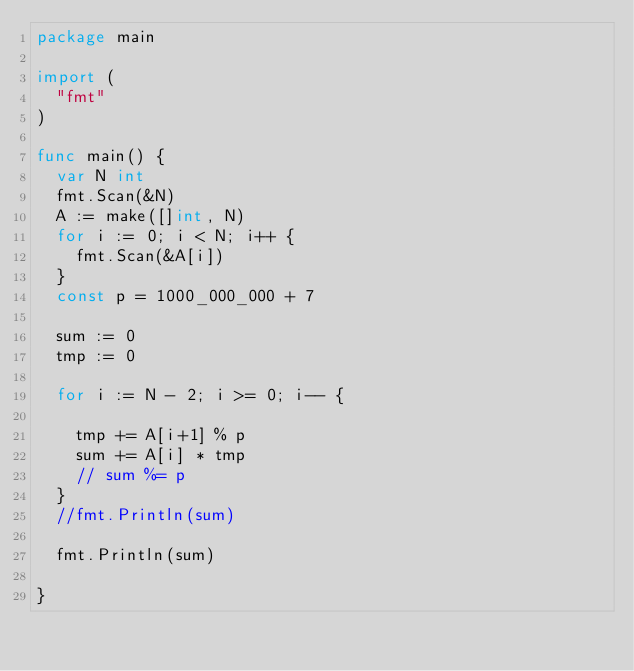Convert code to text. <code><loc_0><loc_0><loc_500><loc_500><_Go_>package main

import (
	"fmt"
)

func main() {
	var N int
	fmt.Scan(&N)
	A := make([]int, N)
	for i := 0; i < N; i++ {
		fmt.Scan(&A[i])
	}
	const p = 1000_000_000 + 7

	sum := 0
	tmp := 0

	for i := N - 2; i >= 0; i-- {

		tmp += A[i+1] % p
		sum += A[i] * tmp
		// sum %= p
	}
	//fmt.Println(sum)

	fmt.Println(sum)

}
</code> 